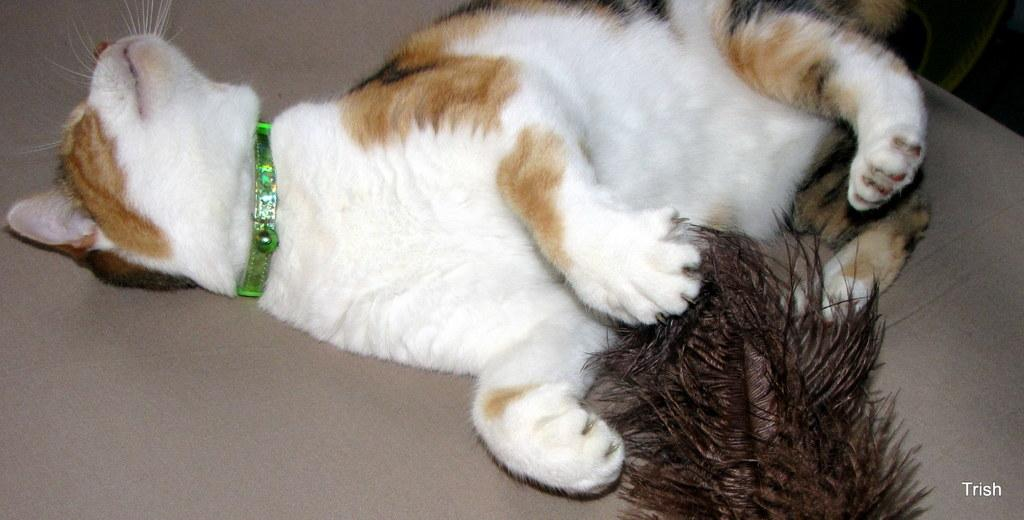What type of animal is present in the image? There is a cat in the image. Can you describe the object with the feather? There is a feather on an object in the image, but the object itself is not specified. What type of volcano can be seen in the image? There is no volcano present in the image. 